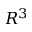Convert formula to latex. <formula><loc_0><loc_0><loc_500><loc_500>R ^ { 3 }</formula> 